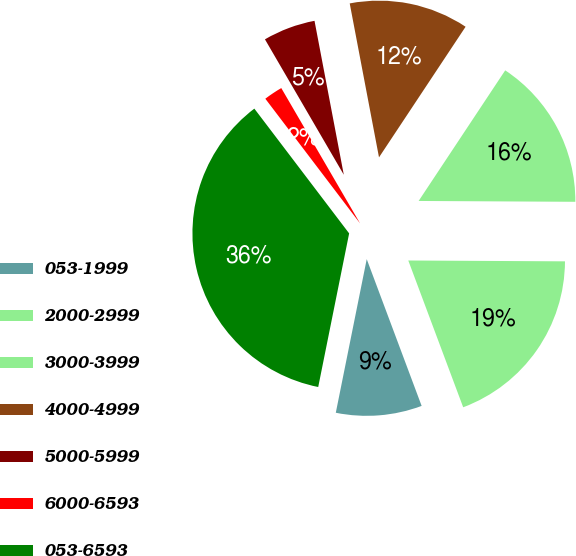<chart> <loc_0><loc_0><loc_500><loc_500><pie_chart><fcel>053-1999<fcel>2000-2999<fcel>3000-3999<fcel>4000-4999<fcel>5000-5999<fcel>6000-6593<fcel>053-6593<nl><fcel>8.86%<fcel>19.22%<fcel>15.77%<fcel>12.31%<fcel>5.4%<fcel>1.95%<fcel>36.5%<nl></chart> 